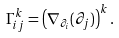<formula> <loc_0><loc_0><loc_500><loc_500>\Gamma _ { i j } ^ { k } = \left ( \nabla _ { \partial _ { i } } ( \partial _ { j } ) \right ) ^ { k } .</formula> 